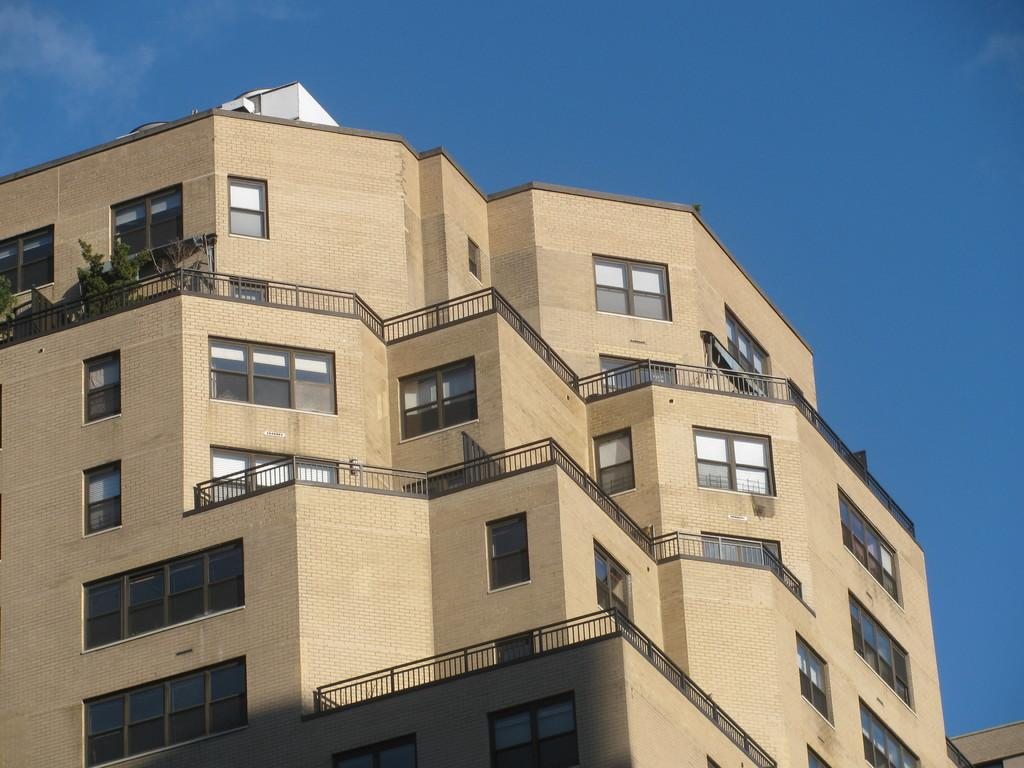What type of structure is present in the image? There is a building in the image. What feature can be observed on the building? The building has glass windows. What type of vegetation is visible in the image? There are plants in the image. What is visible in the background of the image? The sky is visible in the image. What year is depicted on the building in the image? There is no specific year depicted on the building in the image. How many heads can be seen on the plants in the image? There are no heads present on the plants in the image, as plants do not have heads. 